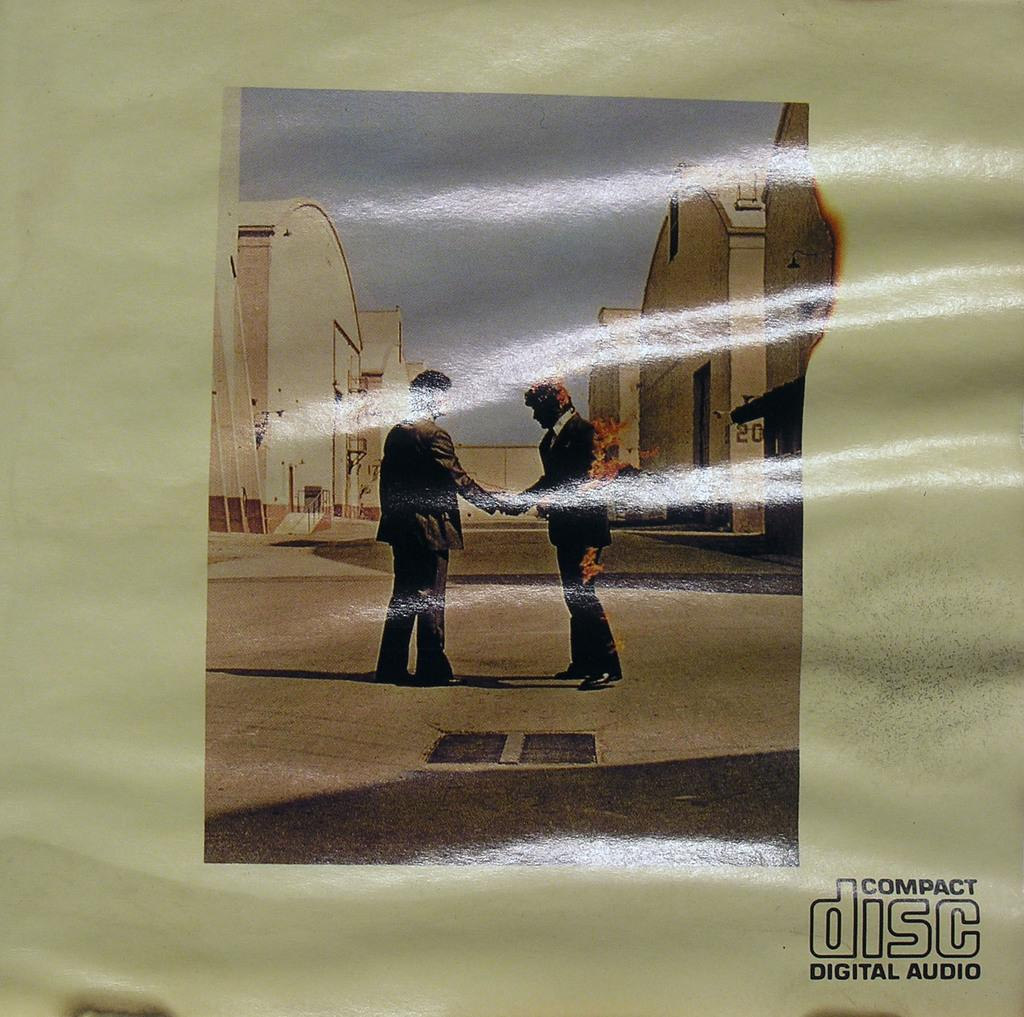What types of subjects are depicted in the image? The image contains depictions of persons and buildings. What is the medium of the image? The depictions are on a paper. Is there any text present in the image? Yes, there is text at the bottom of the image. How many cows are visible in the image? There are no cows present in the image; it contains depictions of persons and buildings. What type of flower is shown in the image? There is no flower depicted in the image. 